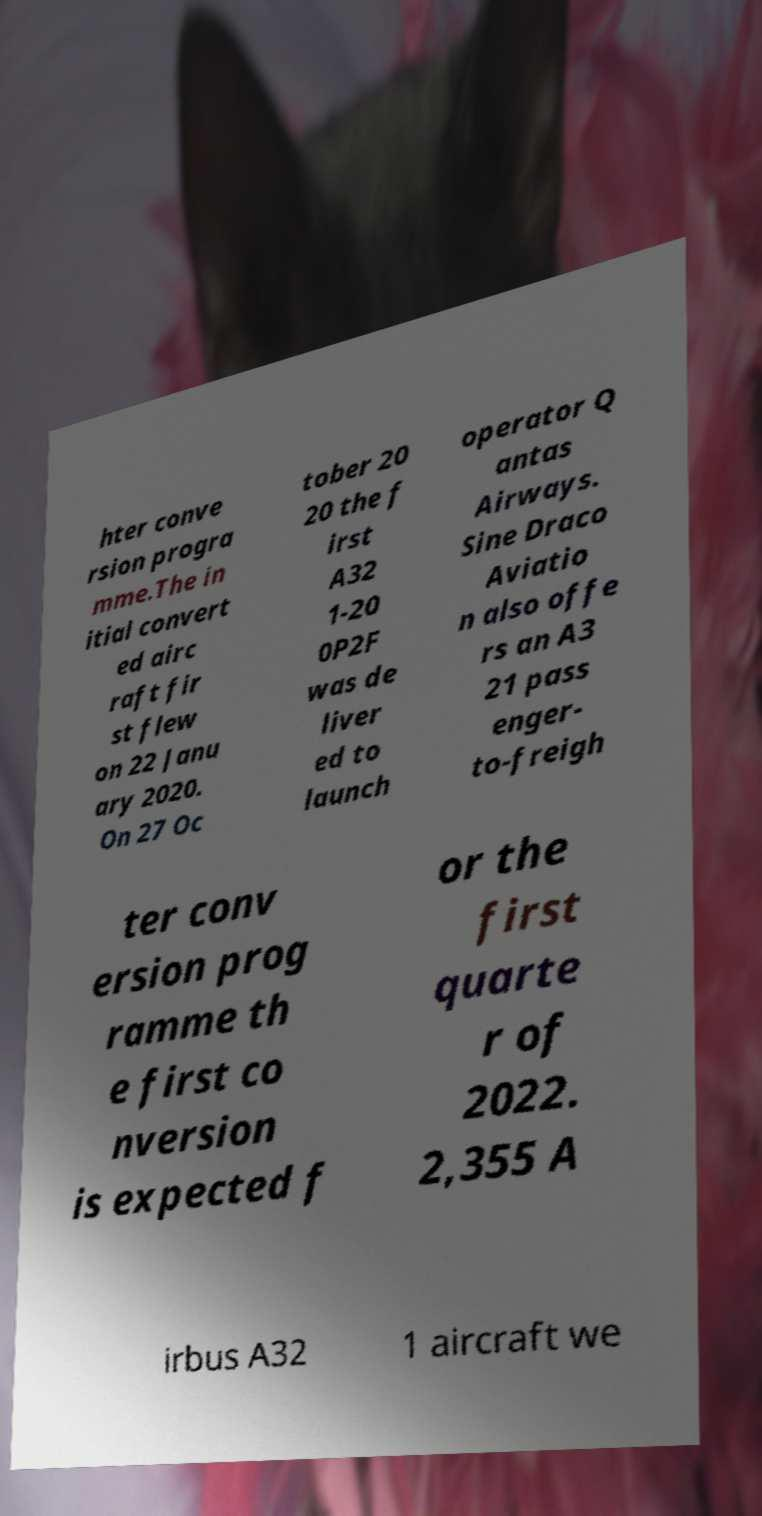Please identify and transcribe the text found in this image. hter conve rsion progra mme.The in itial convert ed airc raft fir st flew on 22 Janu ary 2020. On 27 Oc tober 20 20 the f irst A32 1-20 0P2F was de liver ed to launch operator Q antas Airways. Sine Draco Aviatio n also offe rs an A3 21 pass enger- to-freigh ter conv ersion prog ramme th e first co nversion is expected f or the first quarte r of 2022. 2,355 A irbus A32 1 aircraft we 